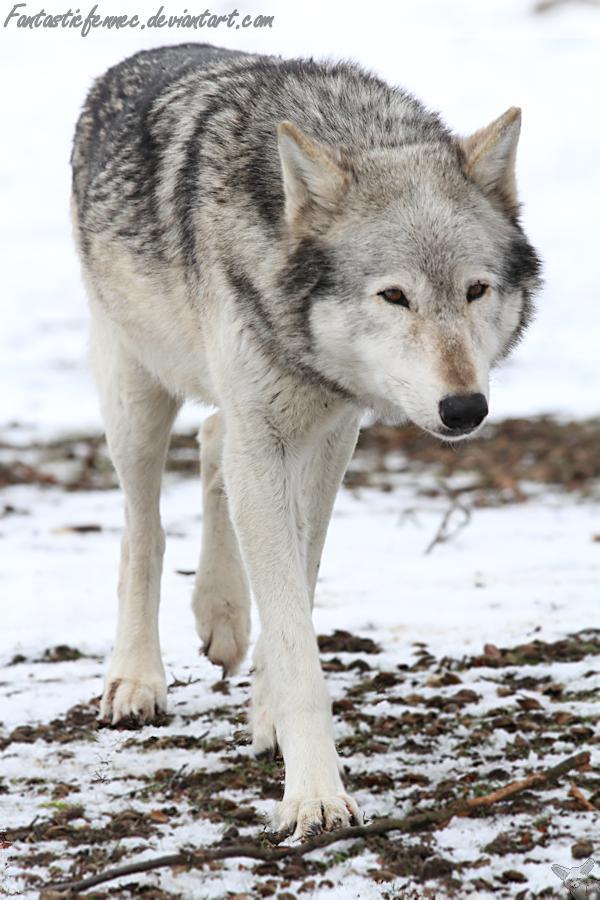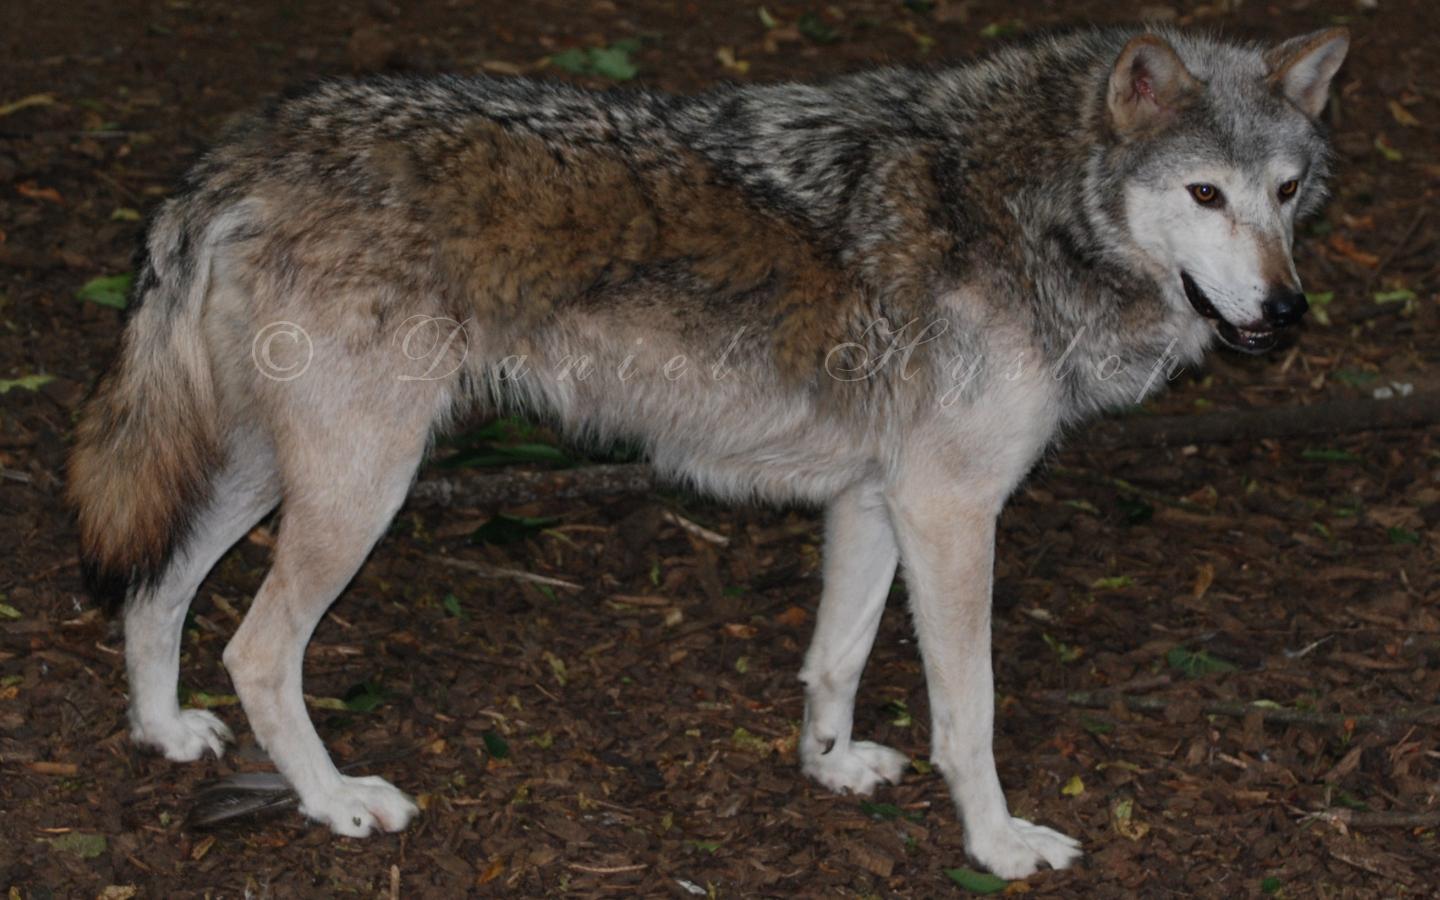The first image is the image on the left, the second image is the image on the right. For the images shown, is this caption "There are a total of four wolves." true? Answer yes or no. No. The first image is the image on the left, the second image is the image on the right. Evaluate the accuracy of this statement regarding the images: "There are at most two wolves total". Is it true? Answer yes or no. Yes. 